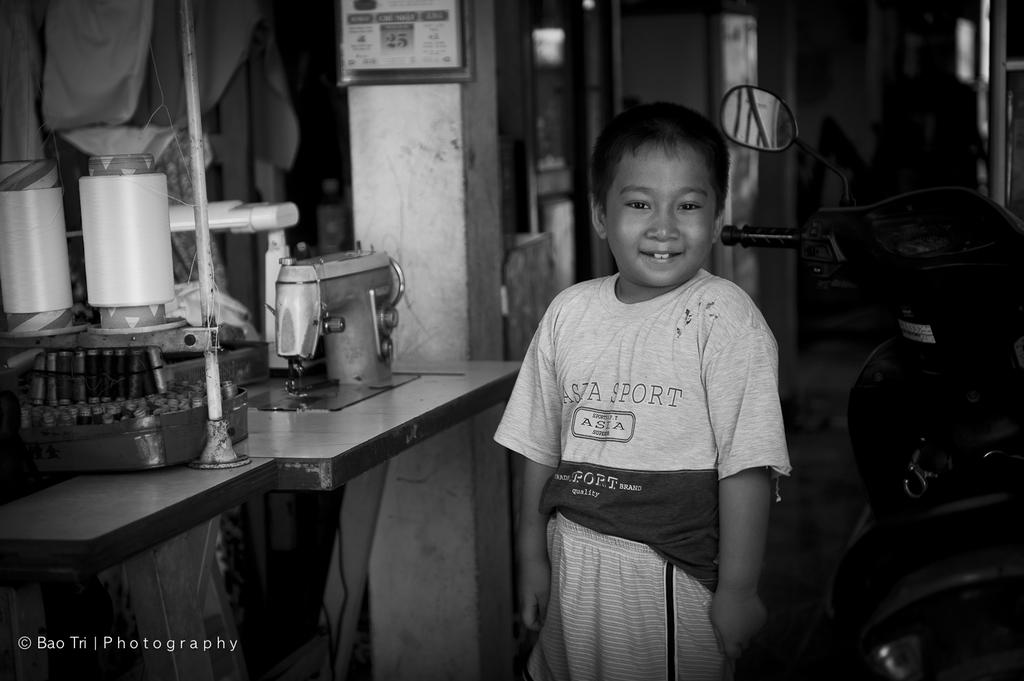What is the color scheme of the image? The image is black and white. Who is present in the image? There is a boy in the image. What is the boy doing in the image? The boy is standing beside a vehicle and posing for the photo. What is the boy's emotional state in the image? The boy is smiling in the image. What is located to the boy's left side in the image? There is equipment to the boy's left side in the image. How many pizzas can be seen in the image? There are no pizzas present in the image. What type of person is the fireman in the image? There is no fireman present in the image; it features a boy standing beside a vehicle. 